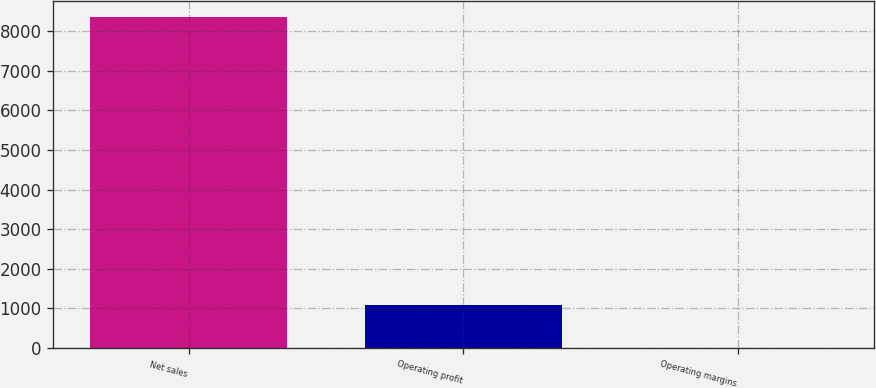<chart> <loc_0><loc_0><loc_500><loc_500><bar_chart><fcel>Net sales<fcel>Operating profit<fcel>Operating margins<nl><fcel>8347<fcel>1083<fcel>13<nl></chart> 